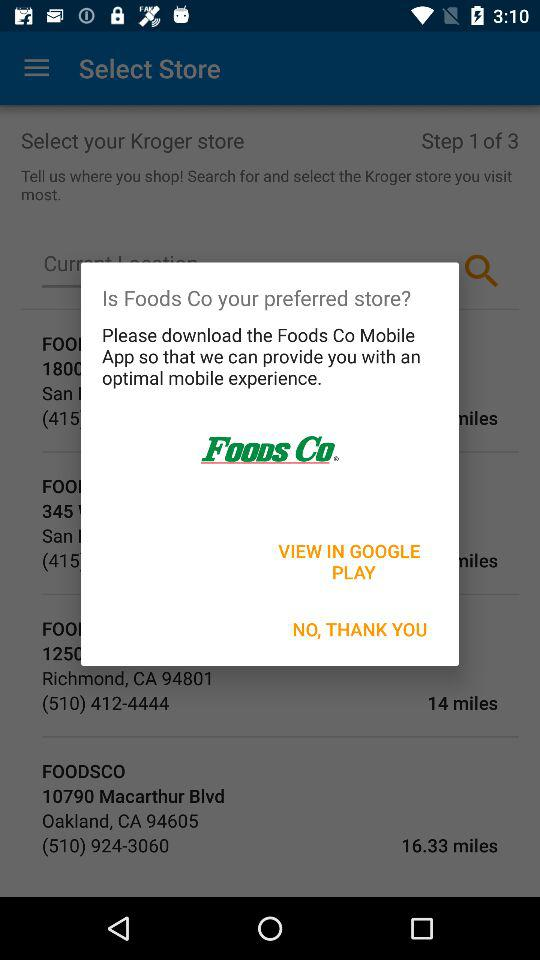Which step is currently going on? Currently, the going on step is 1. 